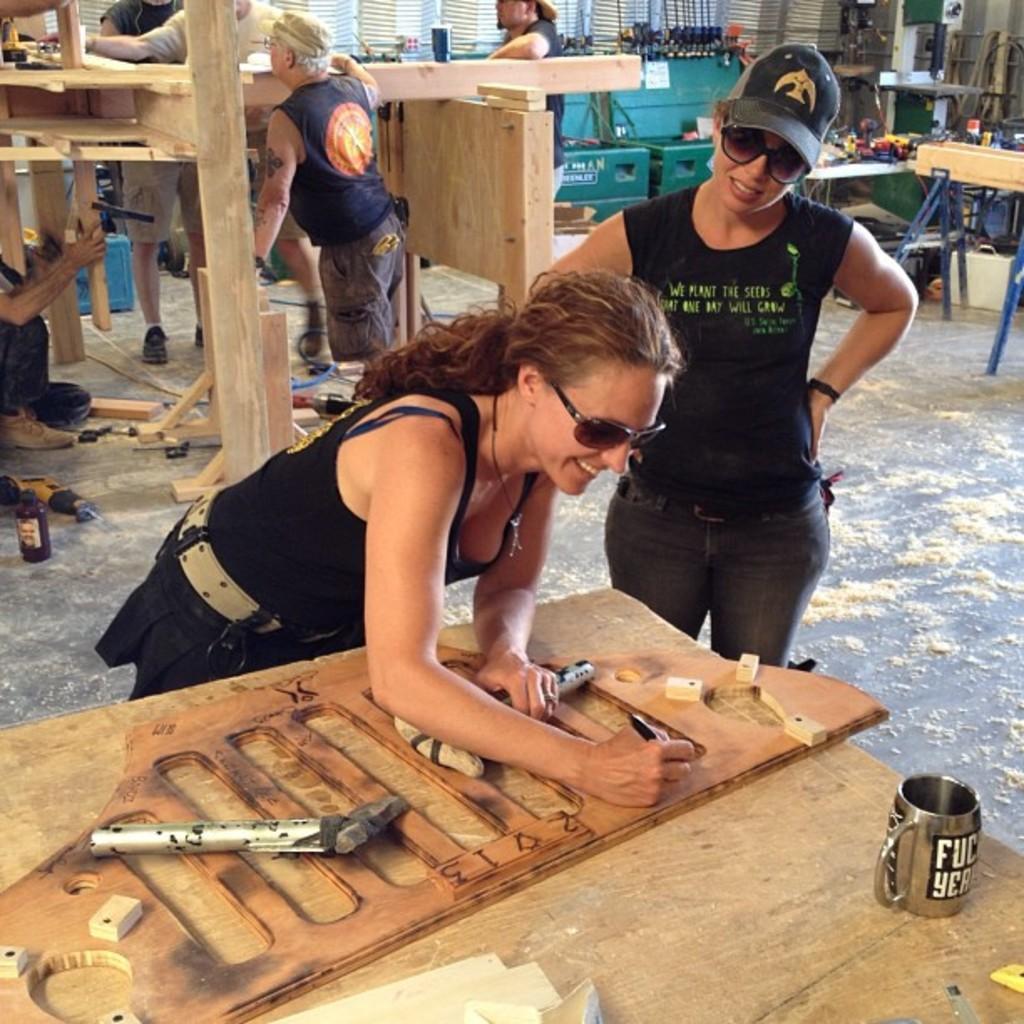How would you summarize this image in a sentence or two? This picture seems to be clicked inside the hall. In the foreground we can see a wooden table on the top of which a mug and some wooden objects and some tools are placed and we can see a woman wearing black color dress, goggles, smiling, holding some objects and seems to be working. On the right we can see another woman wearing black color t-shirt, cap, goggles and standing on the ground. In the background we can see the group of persons and we can see the wooden objects and we can see there are many number of objects placed on the top of the table and we can see the wall, white color objects seems to be the window blinds and many other objects. On the left corner we can see a person seems to be sitting on the ground and there are some objects lying on the ground. 